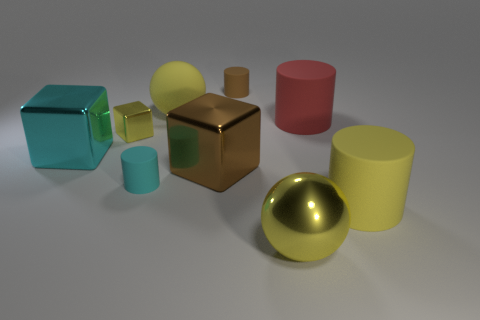Do the small rubber cylinder that is behind the large cyan metal object and the tiny cube have the same color?
Ensure brevity in your answer.  No. Is the number of big yellow matte cylinders that are left of the large brown cube greater than the number of brown shiny objects to the left of the cyan cylinder?
Provide a succinct answer. No. Are there more cyan shiny things than small brown matte spheres?
Ensure brevity in your answer.  Yes. What is the size of the metal thing that is behind the cyan rubber object and right of the cyan matte object?
Offer a very short reply. Large. The small yellow object has what shape?
Your answer should be compact. Cube. Is there any other thing that has the same size as the yellow matte cylinder?
Offer a terse response. Yes. Is the number of yellow metallic spheres that are on the right side of the large yellow cylinder greater than the number of big red things?
Make the answer very short. No. The big yellow matte object to the left of the small matte cylinder on the right side of the large sphere that is behind the tiny yellow cube is what shape?
Provide a succinct answer. Sphere. There is a yellow sphere left of the brown matte thing; is it the same size as the tiny shiny block?
Provide a succinct answer. No. The rubber object that is in front of the brown shiny cube and behind the yellow cylinder has what shape?
Offer a terse response. Cylinder. 